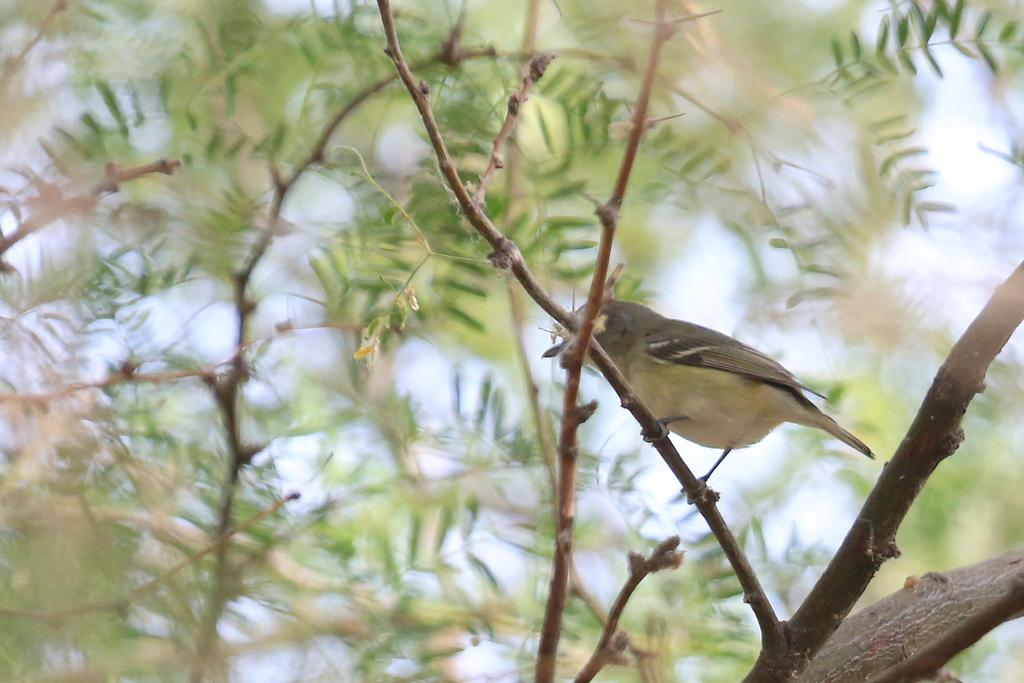What type of animal can be seen on the tree in the image? There is a bird visible on the tree in the image. What is visible in the background behind the tree? The sky is visible behind the tree in the image. What type of plantation can be seen in the image? There is no plantation present in the image; it features a bird on a tree and the sky in the background. What substance is the bird using to climb the tree? Birds do not use a substance to climb trees; they use their claws and beaks to grip the branches. 